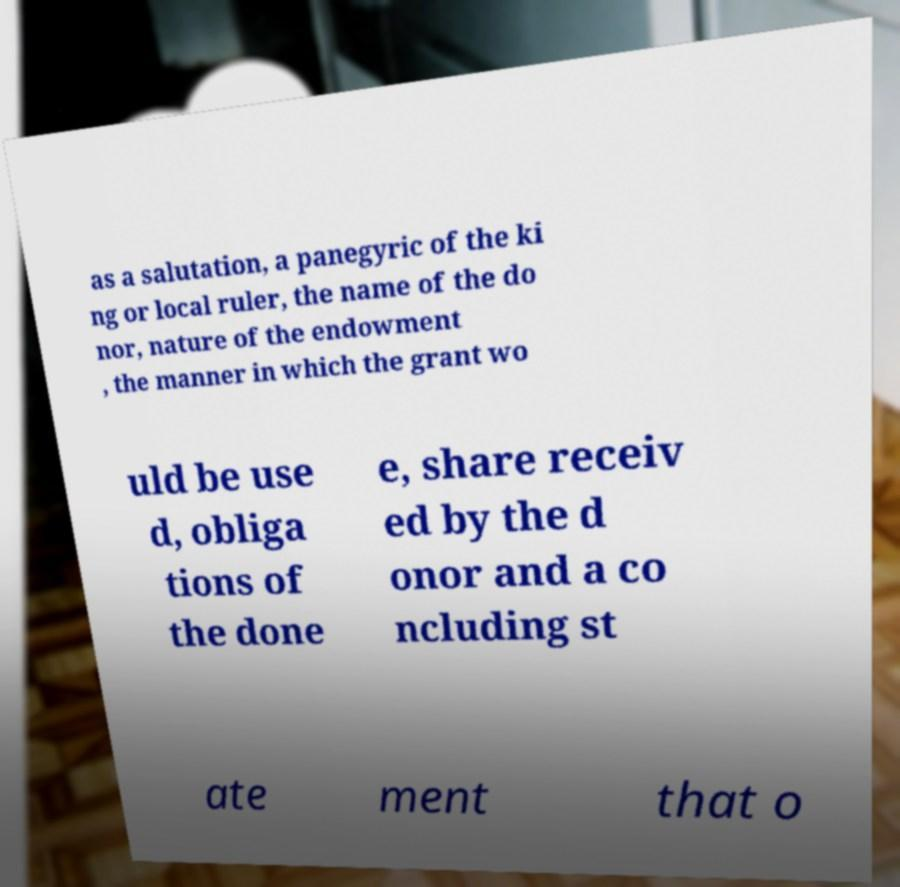Can you accurately transcribe the text from the provided image for me? as a salutation, a panegyric of the ki ng or local ruler, the name of the do nor, nature of the endowment , the manner in which the grant wo uld be use d, obliga tions of the done e, share receiv ed by the d onor and a co ncluding st ate ment that o 